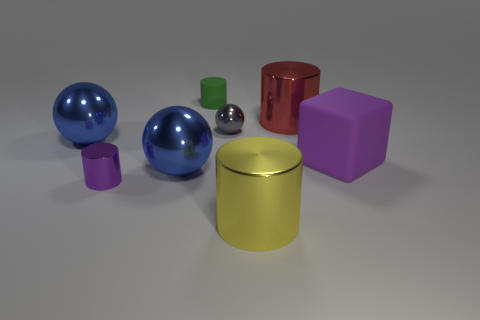Does the tiny green thing have the same shape as the large yellow metallic object?
Your answer should be compact. Yes. What color is the other big shiny object that is the same shape as the red metallic thing?
Give a very brief answer. Yellow. How many small shiny objects are the same color as the tiny matte thing?
Offer a very short reply. 0. What number of things are things in front of the tiny sphere or gray balls?
Offer a terse response. 6. What is the size of the blue metallic sphere left of the small metal cylinder?
Your answer should be compact. Large. Are there fewer big shiny spheres than cylinders?
Offer a terse response. Yes. Are the large thing behind the tiny gray metal sphere and the small cylinder behind the big red metallic cylinder made of the same material?
Provide a short and direct response. No. There is a shiny thing that is to the right of the big cylinder in front of the tiny thing that is to the right of the matte cylinder; what shape is it?
Ensure brevity in your answer.  Cylinder. What number of big spheres are the same material as the big red thing?
Give a very brief answer. 2. There is a tiny metal object right of the small matte object; what number of large metal cylinders are in front of it?
Provide a short and direct response. 1. 